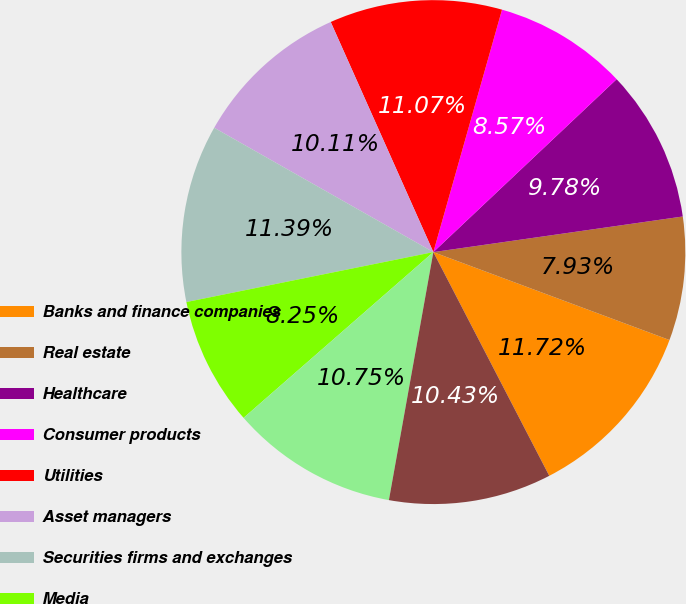<chart> <loc_0><loc_0><loc_500><loc_500><pie_chart><fcel>Banks and finance companies<fcel>Real estate<fcel>Healthcare<fcel>Consumer products<fcel>Utilities<fcel>Asset managers<fcel>Securities firms and exchanges<fcel>Media<fcel>All other<fcel>Total<nl><fcel>11.72%<fcel>7.93%<fcel>9.78%<fcel>8.57%<fcel>11.07%<fcel>10.11%<fcel>11.39%<fcel>8.25%<fcel>10.75%<fcel>10.43%<nl></chart> 